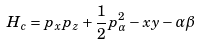<formula> <loc_0><loc_0><loc_500><loc_500>H _ { c } = p _ { x } p _ { z } + \frac { 1 } { 2 } p _ { \alpha } ^ { 2 } - x y - \alpha \beta</formula> 